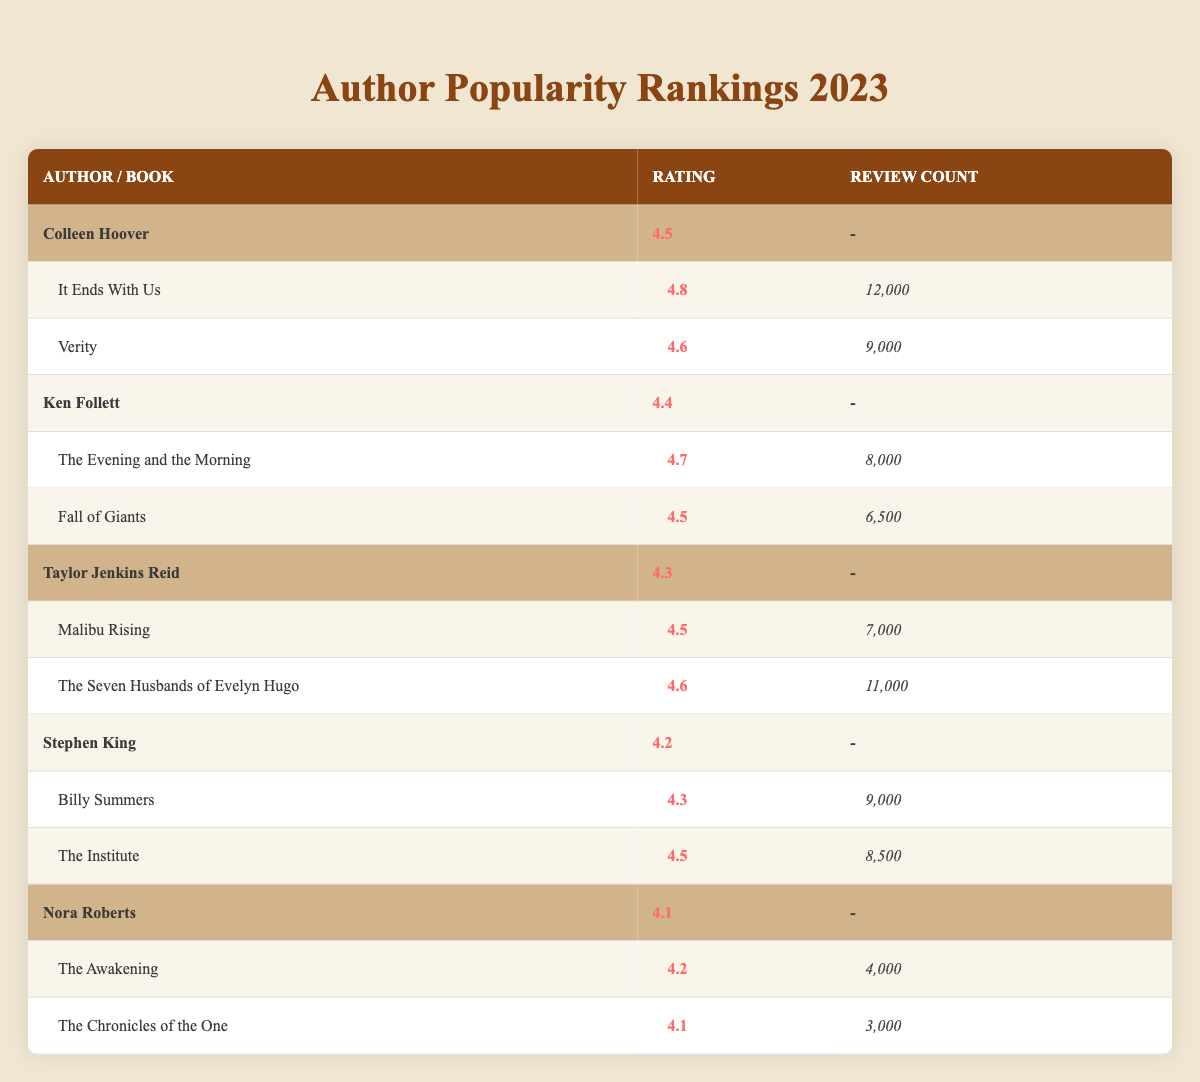What is the average rating of Ken Follett's books? To find the average rating, we examine the book reviews of Ken Follett, which include two books: "The Evening and the Morning" rated 4.7 and "Fall of Giants" rated 4.5. We sum these ratings (4.7 + 4.5 = 9.2) and divide by the number of books (2), giving an average rating of 4.6.
Answer: 4.6 Which author has the highest average rating? By reviewing the average ratings of all authors, Colleen Hoover has an average rating of 4.5, Ken Follett has 4.4, Taylor Jenkins Reid has 4.3, Stephen King has 4.2, and Nora Roberts has 4.1. Since 4.5 is the highest among these numbers, Colleen Hoover is the author with the highest average rating.
Answer: Colleen Hoover How many total reviews did Stephen King's books receive? Stephen King's books received reviews from "Billy Summers" with 9,000 and "The Institute" with 8,500. To find the total reviews, we sum these numbers (9000 + 8500 = 17500), resulting in a total of 17,500 reviews.
Answer: 17500 Is Taylor Jenkins Reid's highest-rated book rated above 4.6? Taylor Jenkins Reid has two books: "Malibu Rising" rated 4.5 and "The Seven Husbands of Evelyn Hugo" rated 4.6. The highest rating (4.6) is not above 4.6; therefore, the answer is no.
Answer: No Which author has the least number of reviews for their book? Looking through the review counts, Nora Roberts has two books, "The Awakening" with 4,000 reviews and "The Chronicles of the One" with 3,000 reviews. The lowest count among these is 3,000 reviews for "The Chronicles of the One," making Nora Roberts the author with the least number of reviews for a single book.
Answer: Nora Roberts 